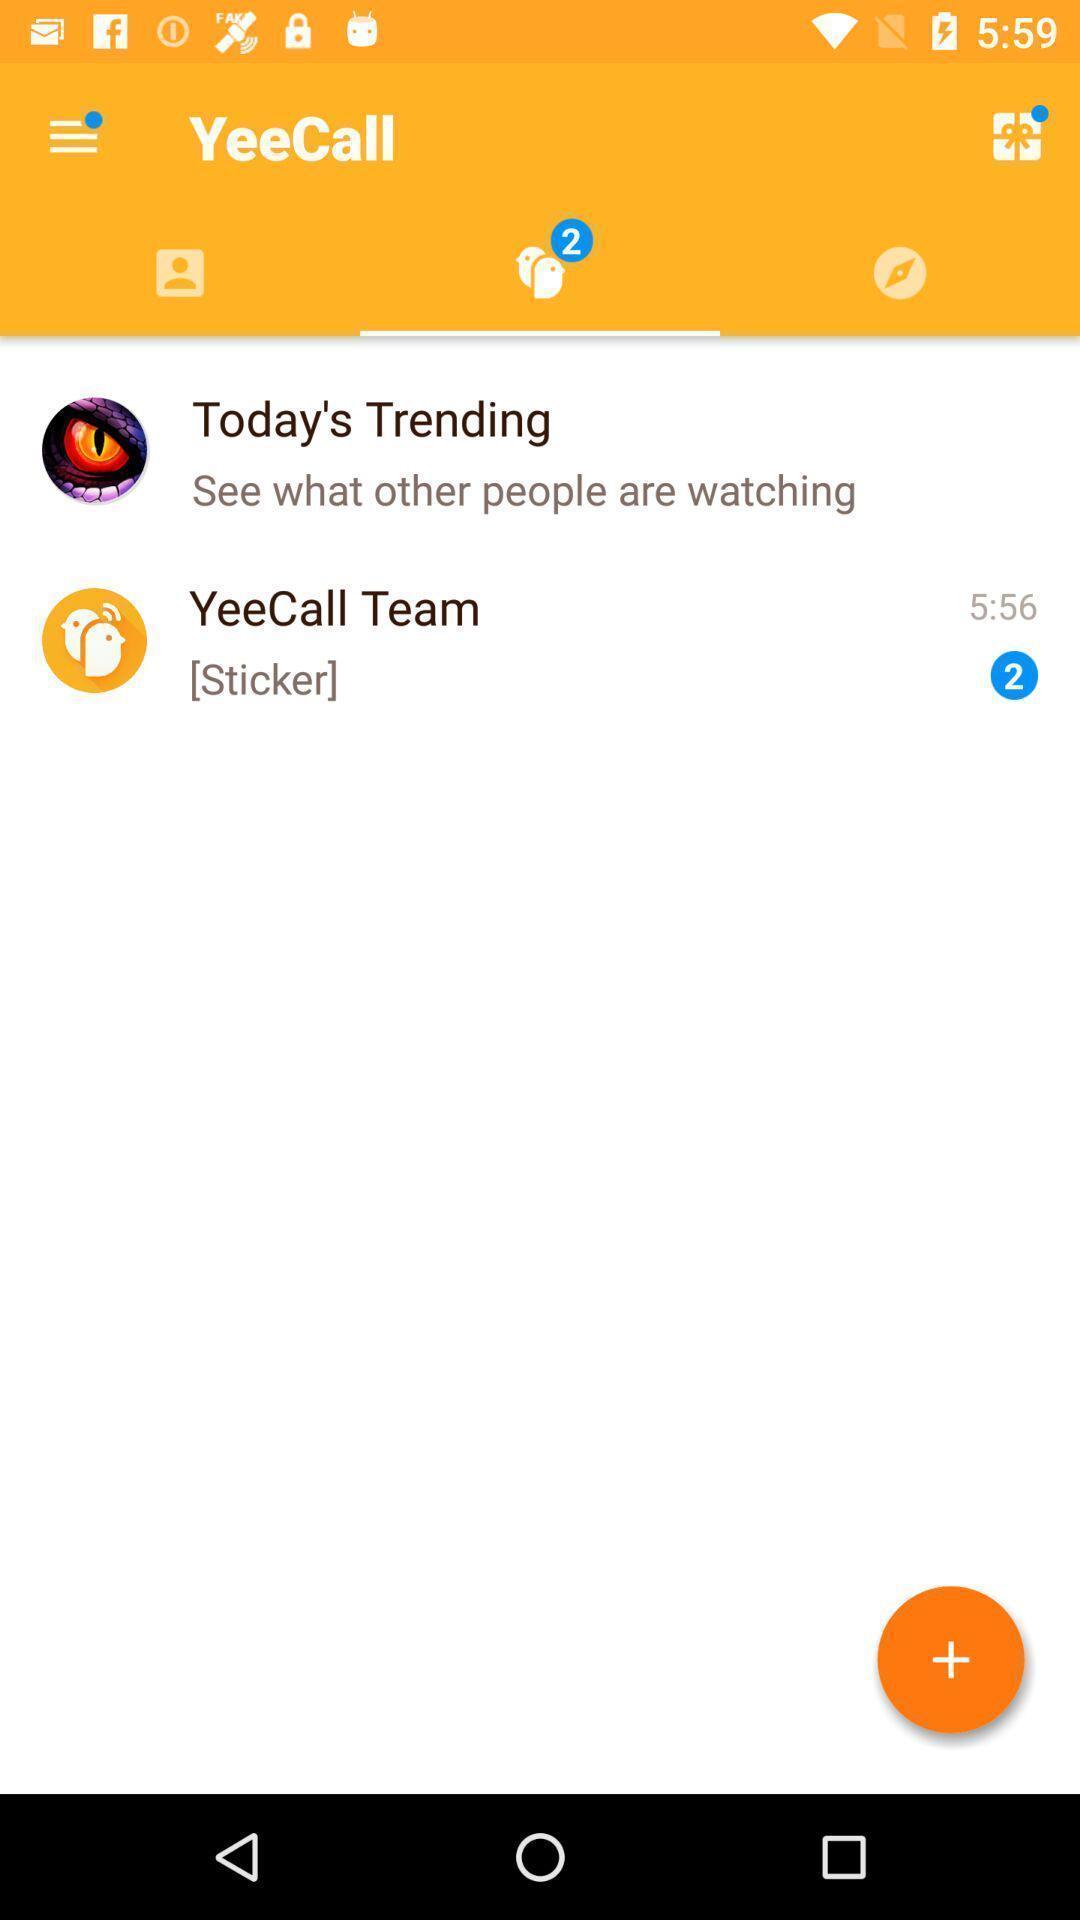Explain the elements present in this screenshot. Screen shows features of video call app. 